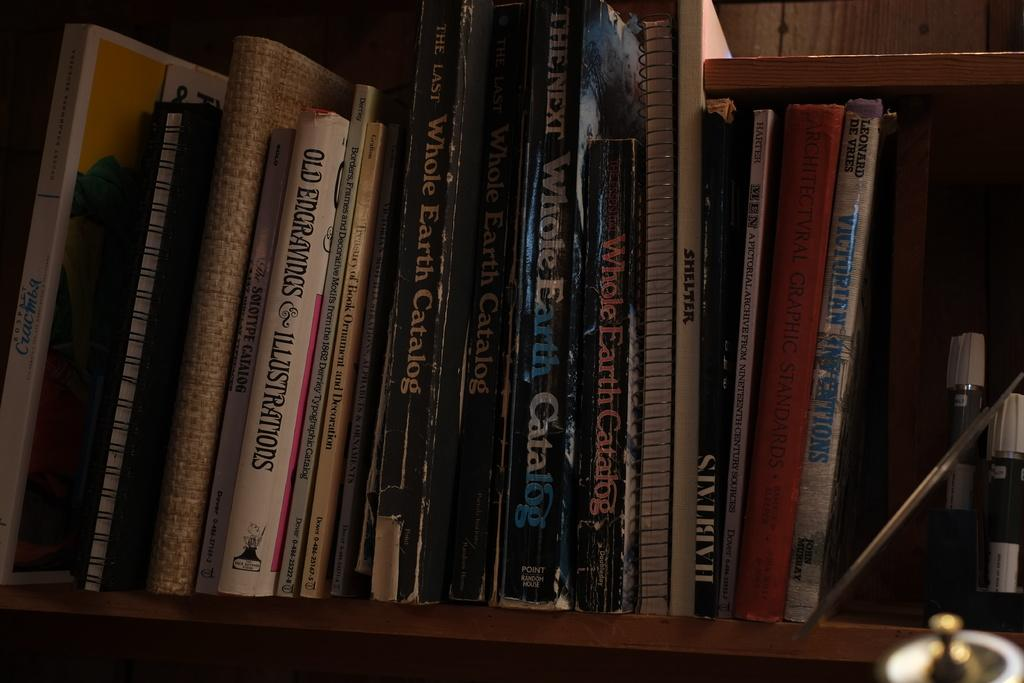<image>
Summarize the visual content of the image. A SHELF WITH NOOKTBOOKS AND BOOKS, ONE BOOK IS THE WHOLE EARTH CATALOG. 